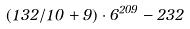Convert formula to latex. <formula><loc_0><loc_0><loc_500><loc_500>( 1 3 2 / 1 0 + 9 ) \cdot 6 ^ { 2 0 9 } - 2 3 2</formula> 